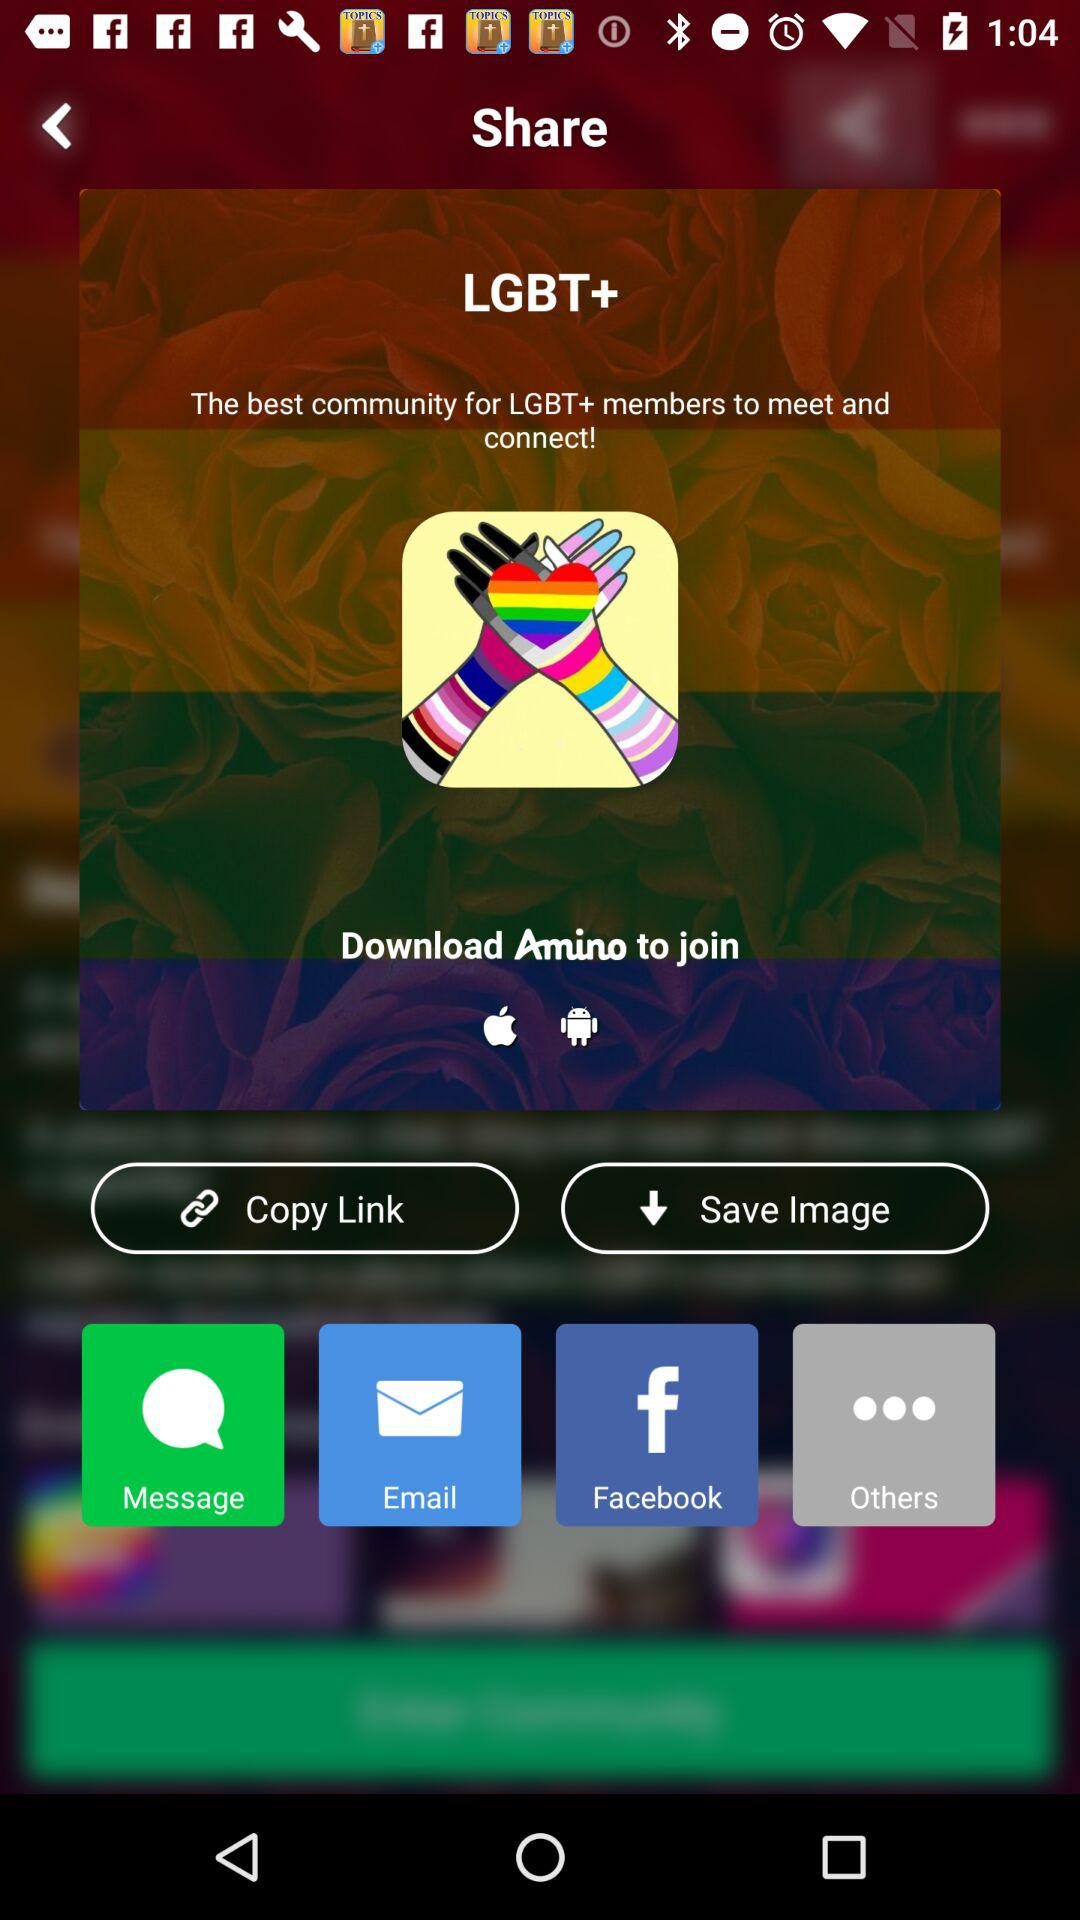How many people have downloaded "Amino"?
When the provided information is insufficient, respond with <no answer>. <no answer> 